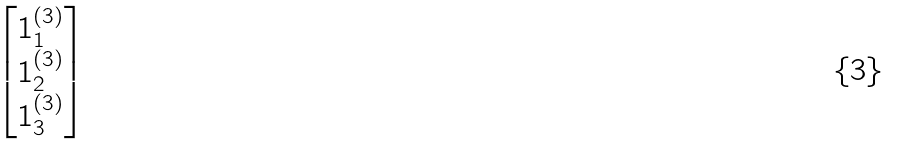Convert formula to latex. <formula><loc_0><loc_0><loc_500><loc_500>\begin{bmatrix} 1 _ { 1 } ^ { ( 3 ) } \\ 1 _ { 2 } ^ { ( 3 ) } \\ 1 _ { 3 } ^ { ( 3 ) } \end{bmatrix}</formula> 